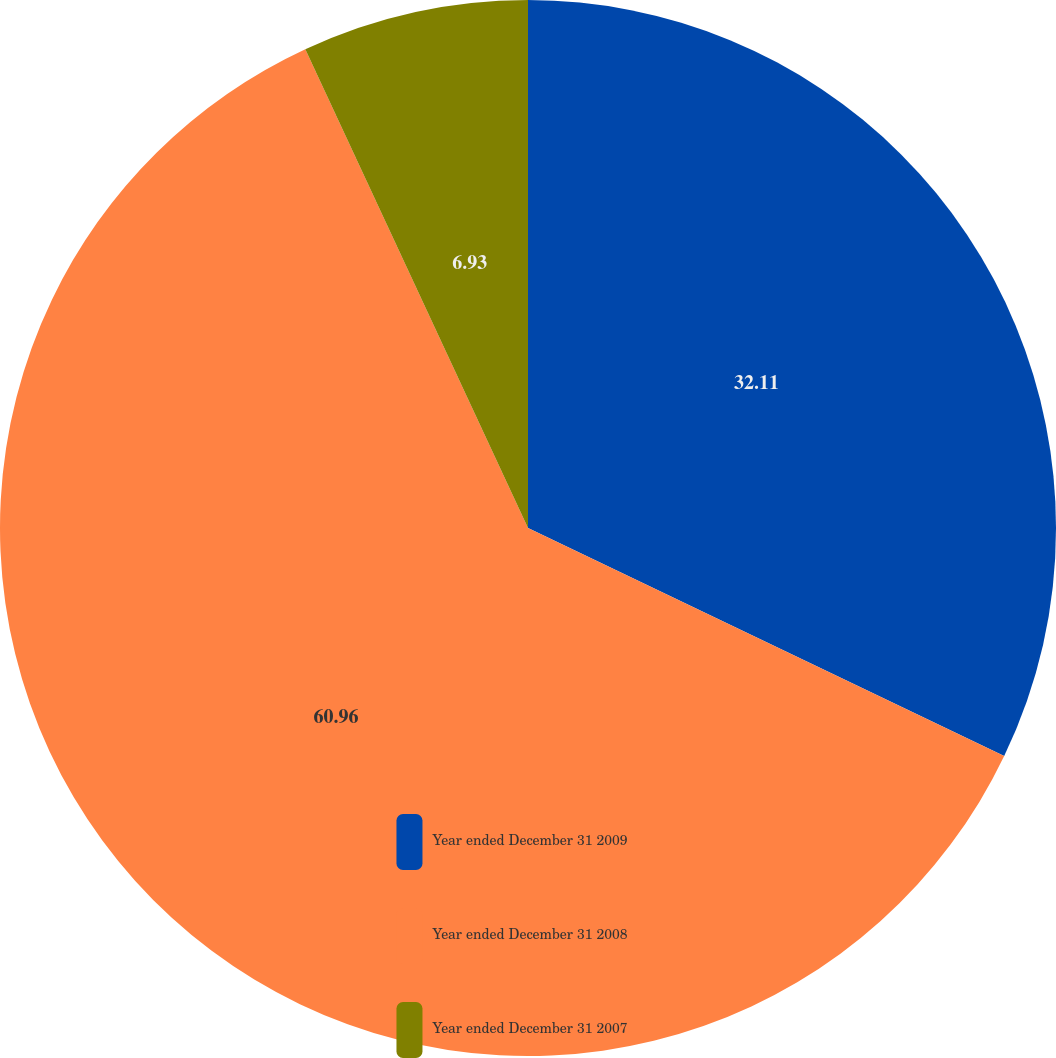Convert chart to OTSL. <chart><loc_0><loc_0><loc_500><loc_500><pie_chart><fcel>Year ended December 31 2009<fcel>Year ended December 31 2008<fcel>Year ended December 31 2007<nl><fcel>32.11%<fcel>60.96%<fcel>6.93%<nl></chart> 